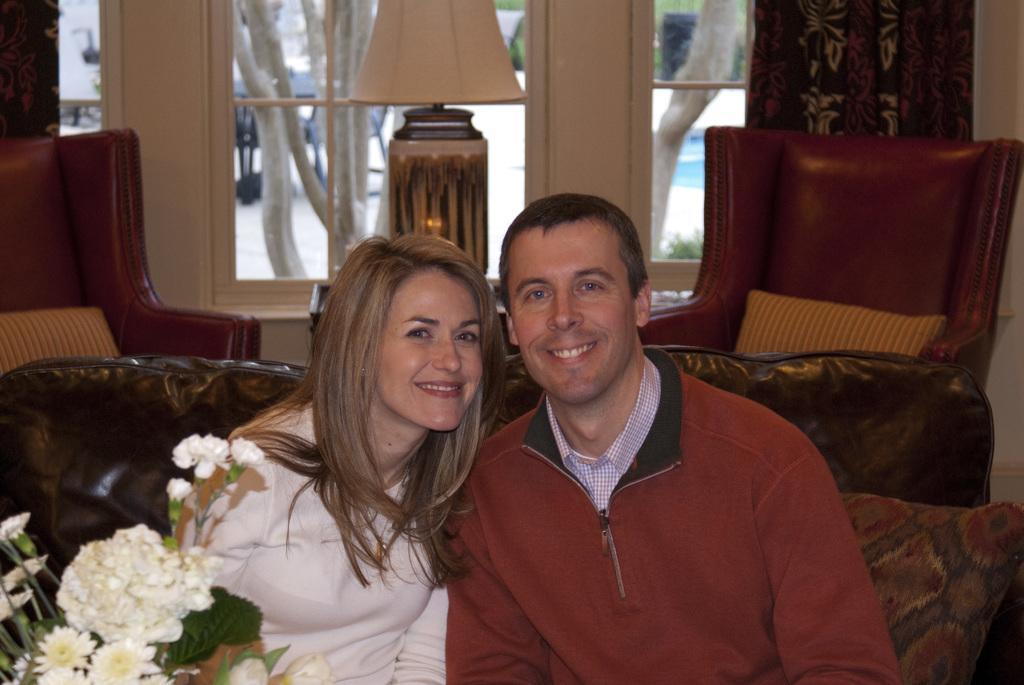In one or two sentences, can you explain what this image depicts? In the background we can see the windows. Through the glass outside view is visible. We can see the branches and few objects. In this picture we can see the curtains, chairs, pillows and lamp. We can see a man and a woman sitting on a sofa. They both are smiling. In the bottom left corner of the picture we can see the flowers, leaves and stems. 